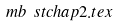<formula> <loc_0><loc_0><loc_500><loc_500>\ m b \ s t c h a p 2 . t e x</formula> 